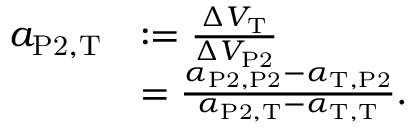Convert formula to latex. <formula><loc_0><loc_0><loc_500><loc_500>\begin{array} { r l } { a _ { P 2 , T } } & { \colon = \frac { \Delta V _ { T } } { \Delta V _ { P 2 } } } \\ & { = \frac { \alpha _ { P 2 , P 2 } - \alpha _ { T , P 2 } } { \alpha _ { P 2 , T } - \alpha _ { T , T } } . } \end{array}</formula> 